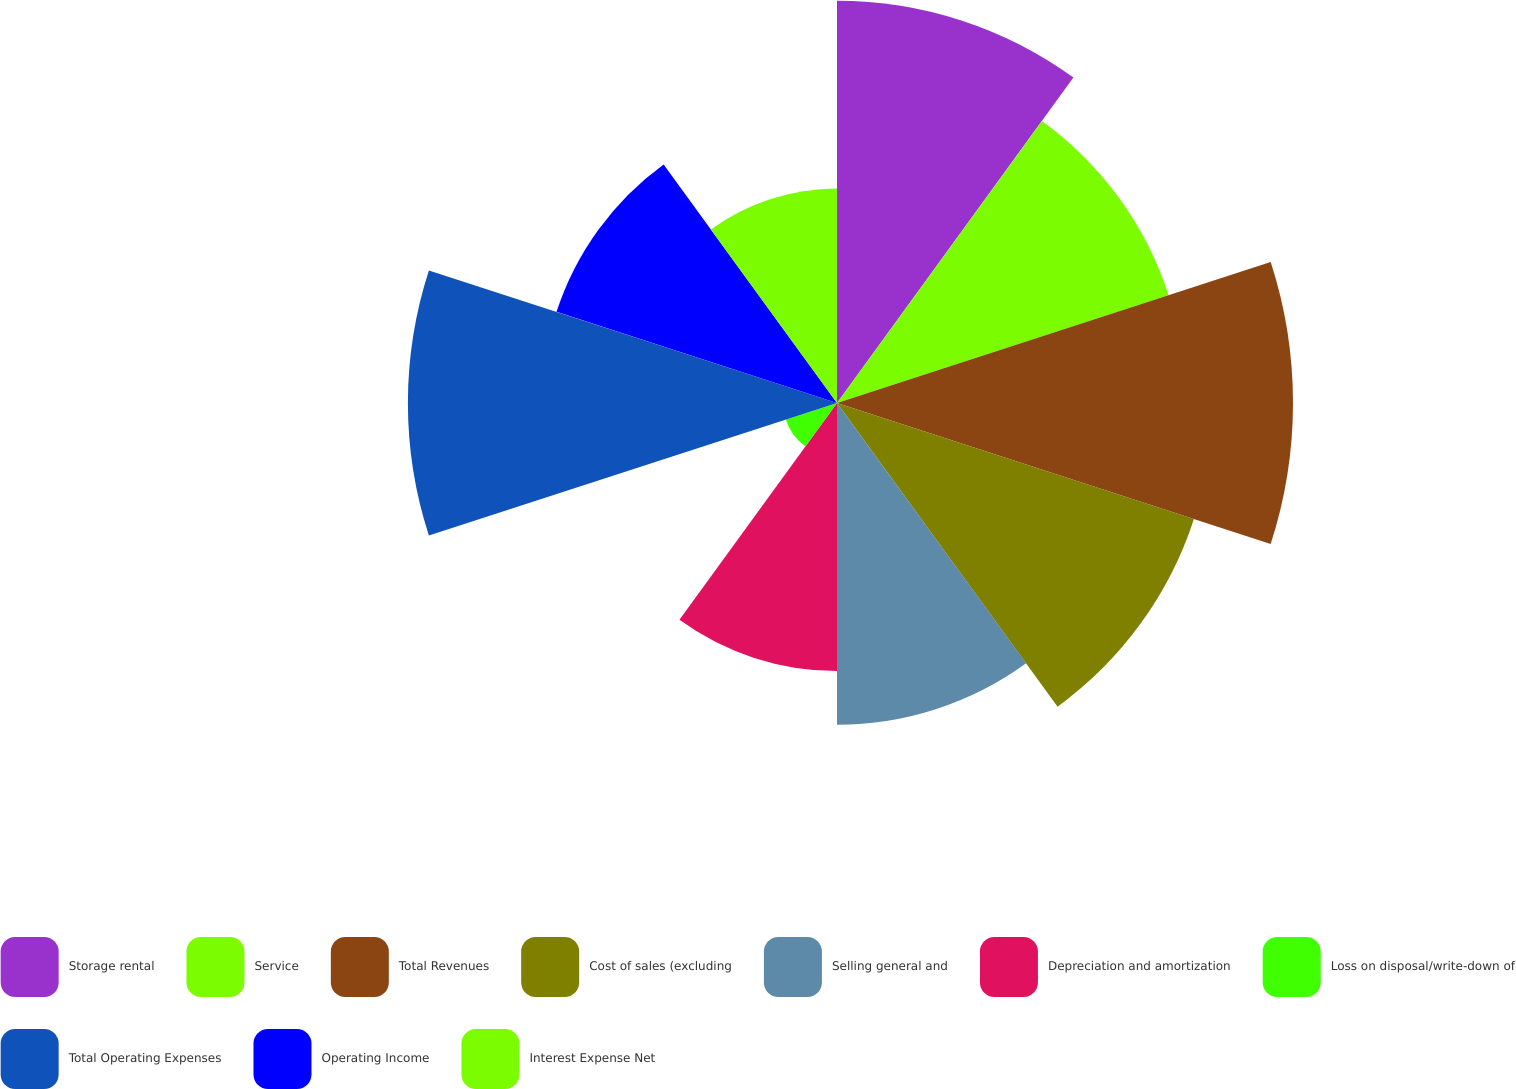Convert chart to OTSL. <chart><loc_0><loc_0><loc_500><loc_500><pie_chart><fcel>Storage rental<fcel>Service<fcel>Total Revenues<fcel>Cost of sales (excluding<fcel>Selling general and<fcel>Depreciation and amortization<fcel>Loss on disposal/write-down of<fcel>Total Operating Expenses<fcel>Operating Income<fcel>Interest Expense Net<nl><fcel>12.71%<fcel>11.02%<fcel>14.41%<fcel>11.86%<fcel>10.17%<fcel>8.47%<fcel>1.7%<fcel>13.56%<fcel>9.32%<fcel>6.78%<nl></chart> 